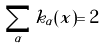Convert formula to latex. <formula><loc_0><loc_0><loc_500><loc_500>\sum _ { \alpha } k _ { \alpha } ( x ) = 2</formula> 